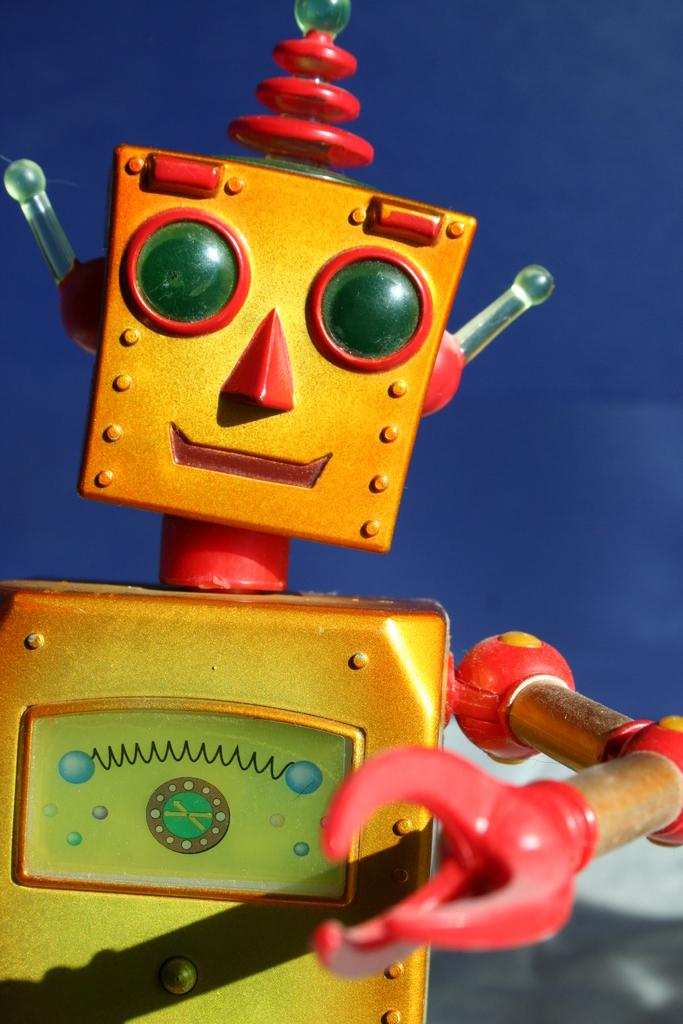What object can be seen in the image? There is a toy in the image. What color is the background of the image? The background of the image is blue. Can you see any roses in the image? There are no roses present in the image. Is there a zoo visible in the background of the image? There is no zoo visible in the image; the background is blue. Are there any ghosts visible in the image? There are no ghosts present in the image. 